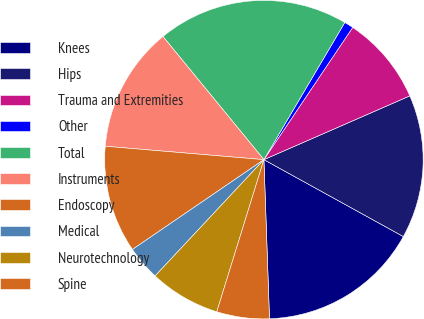Convert chart to OTSL. <chart><loc_0><loc_0><loc_500><loc_500><pie_chart><fcel>Knees<fcel>Hips<fcel>Trauma and Extremities<fcel>Other<fcel>Total<fcel>Instruments<fcel>Endoscopy<fcel>Medical<fcel>Neurotechnology<fcel>Spine<nl><fcel>16.42%<fcel>14.58%<fcel>9.03%<fcel>0.93%<fcel>19.41%<fcel>12.73%<fcel>10.88%<fcel>3.49%<fcel>7.19%<fcel>5.34%<nl></chart> 